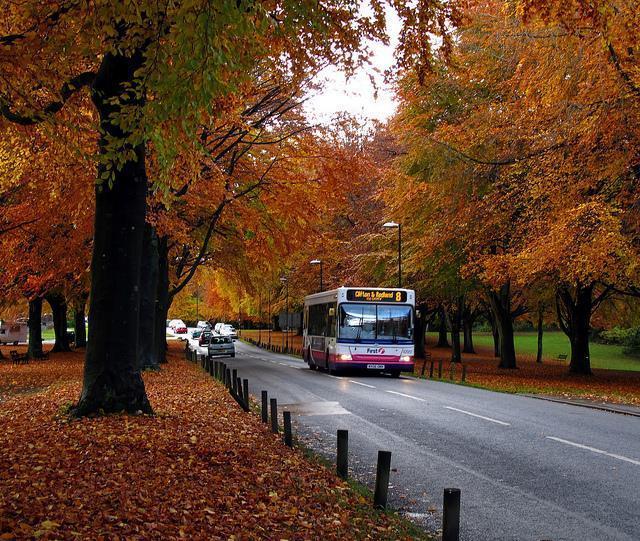How many buses are there?
Give a very brief answer. 1. 